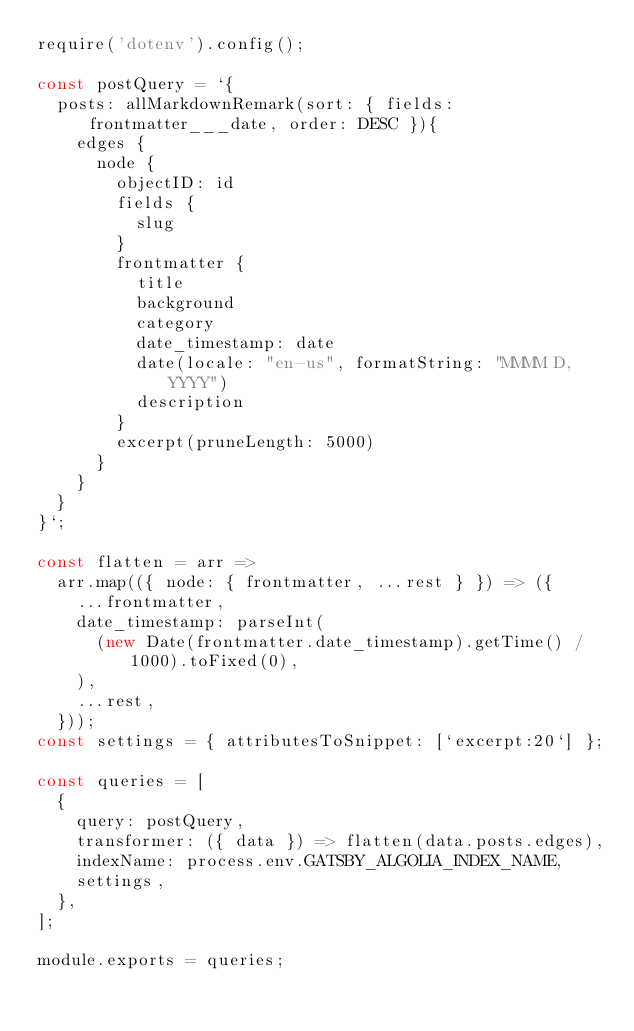Convert code to text. <code><loc_0><loc_0><loc_500><loc_500><_JavaScript_>require('dotenv').config();

const postQuery = `{
  posts: allMarkdownRemark(sort: { fields: frontmatter___date, order: DESC }){
    edges {
      node {
        objectID: id
        fields {
          slug
        }
        frontmatter {
          title
          background
          category
          date_timestamp: date
          date(locale: "en-us", formatString: "MMMM D, YYYY")
          description
        }
        excerpt(pruneLength: 5000)
      }
    }
  }
}`;

const flatten = arr =>
  arr.map(({ node: { frontmatter, ...rest } }) => ({
    ...frontmatter,
    date_timestamp: parseInt(
      (new Date(frontmatter.date_timestamp).getTime() / 1000).toFixed(0),
    ),
    ...rest,
  }));
const settings = { attributesToSnippet: [`excerpt:20`] };

const queries = [
  {
    query: postQuery,
    transformer: ({ data }) => flatten(data.posts.edges),
    indexName: process.env.GATSBY_ALGOLIA_INDEX_NAME,
    settings,
  },
];

module.exports = queries;
</code> 